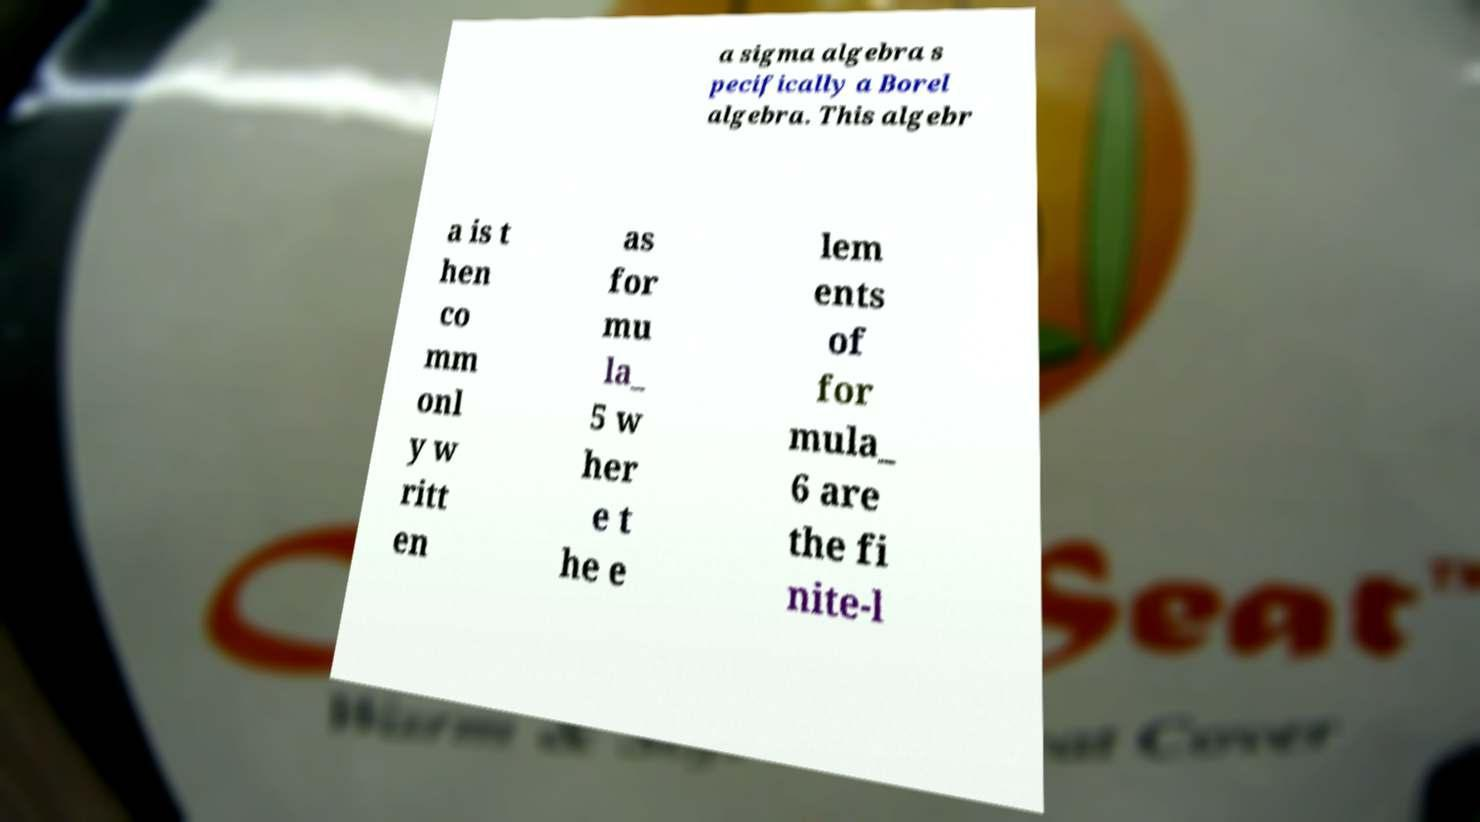Can you accurately transcribe the text from the provided image for me? a sigma algebra s pecifically a Borel algebra. This algebr a is t hen co mm onl y w ritt en as for mu la_ 5 w her e t he e lem ents of for mula_ 6 are the fi nite-l 